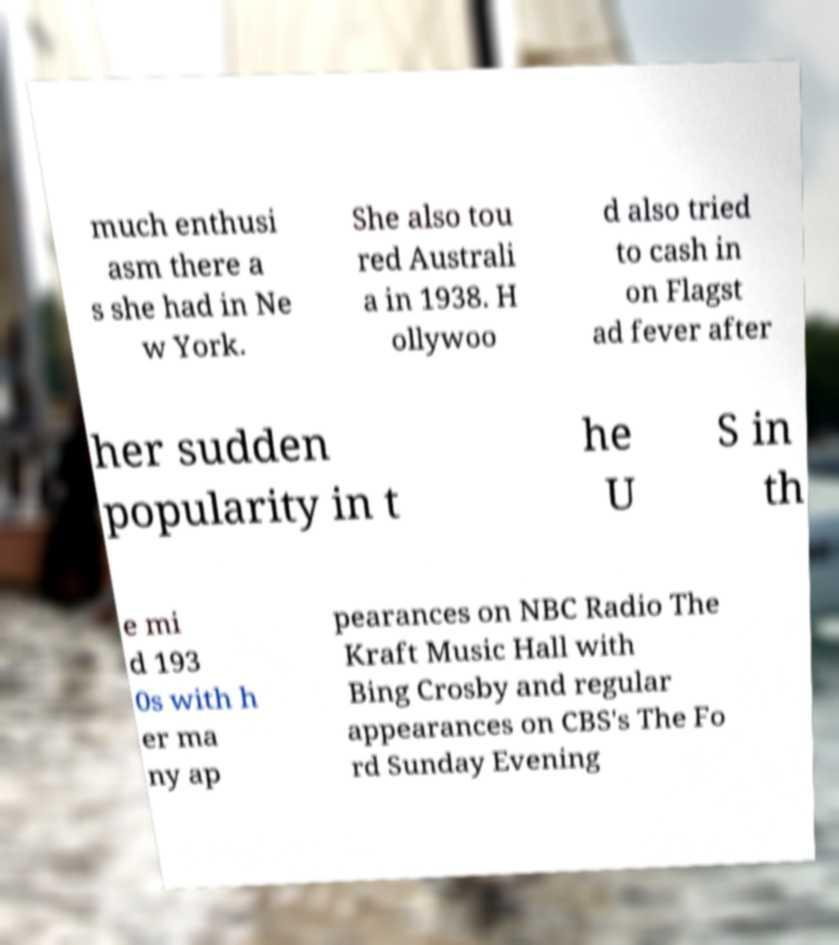What messages or text are displayed in this image? I need them in a readable, typed format. much enthusi asm there a s she had in Ne w York. She also tou red Australi a in 1938. H ollywoo d also tried to cash in on Flagst ad fever after her sudden popularity in t he U S in th e mi d 193 0s with h er ma ny ap pearances on NBC Radio The Kraft Music Hall with Bing Crosby and regular appearances on CBS's The Fo rd Sunday Evening 